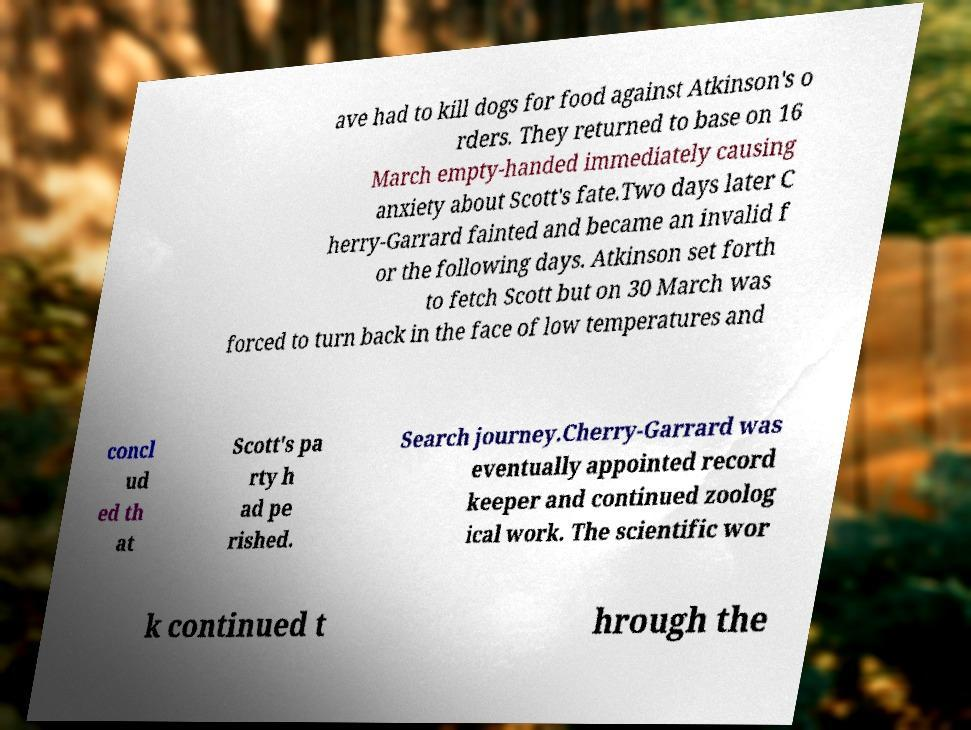Please identify and transcribe the text found in this image. ave had to kill dogs for food against Atkinson's o rders. They returned to base on 16 March empty-handed immediately causing anxiety about Scott's fate.Two days later C herry-Garrard fainted and became an invalid f or the following days. Atkinson set forth to fetch Scott but on 30 March was forced to turn back in the face of low temperatures and concl ud ed th at Scott's pa rty h ad pe rished. Search journey.Cherry-Garrard was eventually appointed record keeper and continued zoolog ical work. The scientific wor k continued t hrough the 